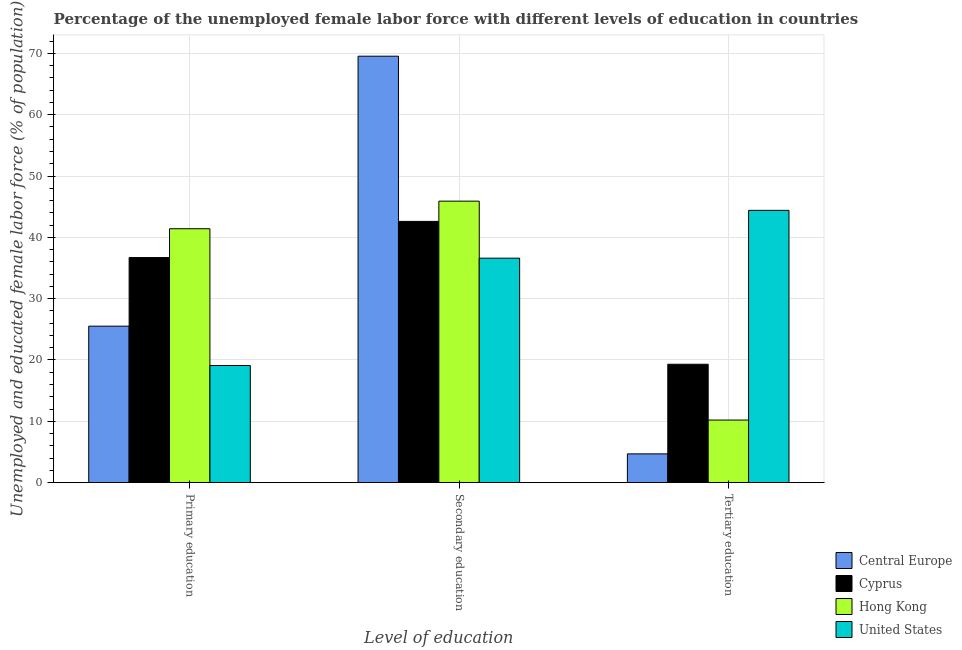How many different coloured bars are there?
Keep it short and to the point. 4. Are the number of bars per tick equal to the number of legend labels?
Your response must be concise. Yes. How many bars are there on the 2nd tick from the left?
Provide a short and direct response. 4. What is the label of the 3rd group of bars from the left?
Make the answer very short. Tertiary education. What is the percentage of female labor force who received tertiary education in Central Europe?
Keep it short and to the point. 4.69. Across all countries, what is the maximum percentage of female labor force who received tertiary education?
Your response must be concise. 44.4. Across all countries, what is the minimum percentage of female labor force who received secondary education?
Offer a very short reply. 36.6. In which country was the percentage of female labor force who received secondary education minimum?
Your answer should be very brief. United States. What is the total percentage of female labor force who received tertiary education in the graph?
Ensure brevity in your answer.  78.59. What is the difference between the percentage of female labor force who received primary education in Cyprus and that in United States?
Your answer should be compact. 17.6. What is the difference between the percentage of female labor force who received tertiary education in Hong Kong and the percentage of female labor force who received primary education in Central Europe?
Offer a terse response. -15.32. What is the average percentage of female labor force who received tertiary education per country?
Keep it short and to the point. 19.65. What is the difference between the percentage of female labor force who received tertiary education and percentage of female labor force who received secondary education in Cyprus?
Your answer should be very brief. -23.3. What is the ratio of the percentage of female labor force who received primary education in United States to that in Central Europe?
Make the answer very short. 0.75. What is the difference between the highest and the second highest percentage of female labor force who received primary education?
Offer a terse response. 4.7. What is the difference between the highest and the lowest percentage of female labor force who received tertiary education?
Your response must be concise. 39.71. What does the 1st bar from the left in Primary education represents?
Keep it short and to the point. Central Europe. What does the 4th bar from the right in Secondary education represents?
Give a very brief answer. Central Europe. Is it the case that in every country, the sum of the percentage of female labor force who received primary education and percentage of female labor force who received secondary education is greater than the percentage of female labor force who received tertiary education?
Your answer should be very brief. Yes. How many bars are there?
Offer a very short reply. 12. How many countries are there in the graph?
Offer a very short reply. 4. What is the difference between two consecutive major ticks on the Y-axis?
Make the answer very short. 10. Does the graph contain grids?
Provide a short and direct response. Yes. Where does the legend appear in the graph?
Provide a succinct answer. Bottom right. What is the title of the graph?
Your response must be concise. Percentage of the unemployed female labor force with different levels of education in countries. Does "Least developed countries" appear as one of the legend labels in the graph?
Keep it short and to the point. No. What is the label or title of the X-axis?
Provide a short and direct response. Level of education. What is the label or title of the Y-axis?
Your answer should be very brief. Unemployed and educated female labor force (% of population). What is the Unemployed and educated female labor force (% of population) in Central Europe in Primary education?
Give a very brief answer. 25.52. What is the Unemployed and educated female labor force (% of population) in Cyprus in Primary education?
Offer a terse response. 36.7. What is the Unemployed and educated female labor force (% of population) in Hong Kong in Primary education?
Offer a very short reply. 41.4. What is the Unemployed and educated female labor force (% of population) in United States in Primary education?
Offer a very short reply. 19.1. What is the Unemployed and educated female labor force (% of population) in Central Europe in Secondary education?
Provide a succinct answer. 69.54. What is the Unemployed and educated female labor force (% of population) of Cyprus in Secondary education?
Provide a succinct answer. 42.6. What is the Unemployed and educated female labor force (% of population) in Hong Kong in Secondary education?
Give a very brief answer. 45.9. What is the Unemployed and educated female labor force (% of population) in United States in Secondary education?
Make the answer very short. 36.6. What is the Unemployed and educated female labor force (% of population) in Central Europe in Tertiary education?
Keep it short and to the point. 4.69. What is the Unemployed and educated female labor force (% of population) in Cyprus in Tertiary education?
Make the answer very short. 19.3. What is the Unemployed and educated female labor force (% of population) of Hong Kong in Tertiary education?
Offer a very short reply. 10.2. What is the Unemployed and educated female labor force (% of population) in United States in Tertiary education?
Offer a very short reply. 44.4. Across all Level of education, what is the maximum Unemployed and educated female labor force (% of population) of Central Europe?
Make the answer very short. 69.54. Across all Level of education, what is the maximum Unemployed and educated female labor force (% of population) of Cyprus?
Provide a succinct answer. 42.6. Across all Level of education, what is the maximum Unemployed and educated female labor force (% of population) in Hong Kong?
Offer a terse response. 45.9. Across all Level of education, what is the maximum Unemployed and educated female labor force (% of population) in United States?
Provide a succinct answer. 44.4. Across all Level of education, what is the minimum Unemployed and educated female labor force (% of population) of Central Europe?
Your answer should be compact. 4.69. Across all Level of education, what is the minimum Unemployed and educated female labor force (% of population) in Cyprus?
Offer a very short reply. 19.3. Across all Level of education, what is the minimum Unemployed and educated female labor force (% of population) of Hong Kong?
Your answer should be compact. 10.2. Across all Level of education, what is the minimum Unemployed and educated female labor force (% of population) of United States?
Provide a short and direct response. 19.1. What is the total Unemployed and educated female labor force (% of population) in Central Europe in the graph?
Make the answer very short. 99.74. What is the total Unemployed and educated female labor force (% of population) in Cyprus in the graph?
Offer a very short reply. 98.6. What is the total Unemployed and educated female labor force (% of population) of Hong Kong in the graph?
Your response must be concise. 97.5. What is the total Unemployed and educated female labor force (% of population) of United States in the graph?
Provide a succinct answer. 100.1. What is the difference between the Unemployed and educated female labor force (% of population) of Central Europe in Primary education and that in Secondary education?
Make the answer very short. -44.02. What is the difference between the Unemployed and educated female labor force (% of population) in Cyprus in Primary education and that in Secondary education?
Offer a terse response. -5.9. What is the difference between the Unemployed and educated female labor force (% of population) of Hong Kong in Primary education and that in Secondary education?
Your answer should be very brief. -4.5. What is the difference between the Unemployed and educated female labor force (% of population) of United States in Primary education and that in Secondary education?
Ensure brevity in your answer.  -17.5. What is the difference between the Unemployed and educated female labor force (% of population) of Central Europe in Primary education and that in Tertiary education?
Offer a terse response. 20.83. What is the difference between the Unemployed and educated female labor force (% of population) of Hong Kong in Primary education and that in Tertiary education?
Keep it short and to the point. 31.2. What is the difference between the Unemployed and educated female labor force (% of population) of United States in Primary education and that in Tertiary education?
Your answer should be compact. -25.3. What is the difference between the Unemployed and educated female labor force (% of population) of Central Europe in Secondary education and that in Tertiary education?
Offer a very short reply. 64.85. What is the difference between the Unemployed and educated female labor force (% of population) in Cyprus in Secondary education and that in Tertiary education?
Offer a terse response. 23.3. What is the difference between the Unemployed and educated female labor force (% of population) of Hong Kong in Secondary education and that in Tertiary education?
Offer a very short reply. 35.7. What is the difference between the Unemployed and educated female labor force (% of population) of Central Europe in Primary education and the Unemployed and educated female labor force (% of population) of Cyprus in Secondary education?
Give a very brief answer. -17.08. What is the difference between the Unemployed and educated female labor force (% of population) of Central Europe in Primary education and the Unemployed and educated female labor force (% of population) of Hong Kong in Secondary education?
Your answer should be very brief. -20.38. What is the difference between the Unemployed and educated female labor force (% of population) of Central Europe in Primary education and the Unemployed and educated female labor force (% of population) of United States in Secondary education?
Your answer should be very brief. -11.08. What is the difference between the Unemployed and educated female labor force (% of population) of Hong Kong in Primary education and the Unemployed and educated female labor force (% of population) of United States in Secondary education?
Make the answer very short. 4.8. What is the difference between the Unemployed and educated female labor force (% of population) in Central Europe in Primary education and the Unemployed and educated female labor force (% of population) in Cyprus in Tertiary education?
Your response must be concise. 6.22. What is the difference between the Unemployed and educated female labor force (% of population) of Central Europe in Primary education and the Unemployed and educated female labor force (% of population) of Hong Kong in Tertiary education?
Your answer should be compact. 15.32. What is the difference between the Unemployed and educated female labor force (% of population) in Central Europe in Primary education and the Unemployed and educated female labor force (% of population) in United States in Tertiary education?
Provide a succinct answer. -18.88. What is the difference between the Unemployed and educated female labor force (% of population) of Cyprus in Primary education and the Unemployed and educated female labor force (% of population) of Hong Kong in Tertiary education?
Keep it short and to the point. 26.5. What is the difference between the Unemployed and educated female labor force (% of population) in Hong Kong in Primary education and the Unemployed and educated female labor force (% of population) in United States in Tertiary education?
Give a very brief answer. -3. What is the difference between the Unemployed and educated female labor force (% of population) in Central Europe in Secondary education and the Unemployed and educated female labor force (% of population) in Cyprus in Tertiary education?
Provide a succinct answer. 50.24. What is the difference between the Unemployed and educated female labor force (% of population) in Central Europe in Secondary education and the Unemployed and educated female labor force (% of population) in Hong Kong in Tertiary education?
Make the answer very short. 59.34. What is the difference between the Unemployed and educated female labor force (% of population) in Central Europe in Secondary education and the Unemployed and educated female labor force (% of population) in United States in Tertiary education?
Ensure brevity in your answer.  25.14. What is the difference between the Unemployed and educated female labor force (% of population) of Cyprus in Secondary education and the Unemployed and educated female labor force (% of population) of Hong Kong in Tertiary education?
Ensure brevity in your answer.  32.4. What is the difference between the Unemployed and educated female labor force (% of population) in Cyprus in Secondary education and the Unemployed and educated female labor force (% of population) in United States in Tertiary education?
Your answer should be very brief. -1.8. What is the average Unemployed and educated female labor force (% of population) in Central Europe per Level of education?
Provide a succinct answer. 33.25. What is the average Unemployed and educated female labor force (% of population) of Cyprus per Level of education?
Offer a very short reply. 32.87. What is the average Unemployed and educated female labor force (% of population) in Hong Kong per Level of education?
Ensure brevity in your answer.  32.5. What is the average Unemployed and educated female labor force (% of population) in United States per Level of education?
Provide a succinct answer. 33.37. What is the difference between the Unemployed and educated female labor force (% of population) in Central Europe and Unemployed and educated female labor force (% of population) in Cyprus in Primary education?
Your answer should be compact. -11.18. What is the difference between the Unemployed and educated female labor force (% of population) in Central Europe and Unemployed and educated female labor force (% of population) in Hong Kong in Primary education?
Make the answer very short. -15.88. What is the difference between the Unemployed and educated female labor force (% of population) of Central Europe and Unemployed and educated female labor force (% of population) of United States in Primary education?
Your answer should be very brief. 6.42. What is the difference between the Unemployed and educated female labor force (% of population) of Cyprus and Unemployed and educated female labor force (% of population) of United States in Primary education?
Your answer should be very brief. 17.6. What is the difference between the Unemployed and educated female labor force (% of population) of Hong Kong and Unemployed and educated female labor force (% of population) of United States in Primary education?
Give a very brief answer. 22.3. What is the difference between the Unemployed and educated female labor force (% of population) of Central Europe and Unemployed and educated female labor force (% of population) of Cyprus in Secondary education?
Provide a short and direct response. 26.94. What is the difference between the Unemployed and educated female labor force (% of population) of Central Europe and Unemployed and educated female labor force (% of population) of Hong Kong in Secondary education?
Ensure brevity in your answer.  23.64. What is the difference between the Unemployed and educated female labor force (% of population) of Central Europe and Unemployed and educated female labor force (% of population) of United States in Secondary education?
Ensure brevity in your answer.  32.94. What is the difference between the Unemployed and educated female labor force (% of population) of Cyprus and Unemployed and educated female labor force (% of population) of Hong Kong in Secondary education?
Keep it short and to the point. -3.3. What is the difference between the Unemployed and educated female labor force (% of population) of Central Europe and Unemployed and educated female labor force (% of population) of Cyprus in Tertiary education?
Offer a terse response. -14.61. What is the difference between the Unemployed and educated female labor force (% of population) in Central Europe and Unemployed and educated female labor force (% of population) in Hong Kong in Tertiary education?
Your response must be concise. -5.51. What is the difference between the Unemployed and educated female labor force (% of population) of Central Europe and Unemployed and educated female labor force (% of population) of United States in Tertiary education?
Keep it short and to the point. -39.71. What is the difference between the Unemployed and educated female labor force (% of population) in Cyprus and Unemployed and educated female labor force (% of population) in United States in Tertiary education?
Make the answer very short. -25.1. What is the difference between the Unemployed and educated female labor force (% of population) in Hong Kong and Unemployed and educated female labor force (% of population) in United States in Tertiary education?
Provide a short and direct response. -34.2. What is the ratio of the Unemployed and educated female labor force (% of population) of Central Europe in Primary education to that in Secondary education?
Provide a succinct answer. 0.37. What is the ratio of the Unemployed and educated female labor force (% of population) of Cyprus in Primary education to that in Secondary education?
Your answer should be very brief. 0.86. What is the ratio of the Unemployed and educated female labor force (% of population) in Hong Kong in Primary education to that in Secondary education?
Your answer should be very brief. 0.9. What is the ratio of the Unemployed and educated female labor force (% of population) in United States in Primary education to that in Secondary education?
Your answer should be very brief. 0.52. What is the ratio of the Unemployed and educated female labor force (% of population) in Central Europe in Primary education to that in Tertiary education?
Offer a terse response. 5.44. What is the ratio of the Unemployed and educated female labor force (% of population) of Cyprus in Primary education to that in Tertiary education?
Offer a terse response. 1.9. What is the ratio of the Unemployed and educated female labor force (% of population) in Hong Kong in Primary education to that in Tertiary education?
Your answer should be compact. 4.06. What is the ratio of the Unemployed and educated female labor force (% of population) in United States in Primary education to that in Tertiary education?
Your answer should be compact. 0.43. What is the ratio of the Unemployed and educated female labor force (% of population) of Central Europe in Secondary education to that in Tertiary education?
Keep it short and to the point. 14.83. What is the ratio of the Unemployed and educated female labor force (% of population) of Cyprus in Secondary education to that in Tertiary education?
Provide a short and direct response. 2.21. What is the ratio of the Unemployed and educated female labor force (% of population) of Hong Kong in Secondary education to that in Tertiary education?
Your answer should be very brief. 4.5. What is the ratio of the Unemployed and educated female labor force (% of population) of United States in Secondary education to that in Tertiary education?
Provide a short and direct response. 0.82. What is the difference between the highest and the second highest Unemployed and educated female labor force (% of population) in Central Europe?
Offer a terse response. 44.02. What is the difference between the highest and the lowest Unemployed and educated female labor force (% of population) in Central Europe?
Your response must be concise. 64.85. What is the difference between the highest and the lowest Unemployed and educated female labor force (% of population) of Cyprus?
Make the answer very short. 23.3. What is the difference between the highest and the lowest Unemployed and educated female labor force (% of population) of Hong Kong?
Offer a very short reply. 35.7. What is the difference between the highest and the lowest Unemployed and educated female labor force (% of population) of United States?
Your response must be concise. 25.3. 